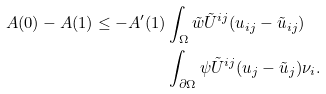<formula> <loc_0><loc_0><loc_500><loc_500>A ( 0 ) - A ( 1 ) \leq - A ^ { \prime } ( 1 ) & \int _ { \Omega } \tilde { w } \tilde { U } ^ { i j } ( u _ { i j } - \tilde { u } _ { i j } ) \\ & \int _ { \partial \Omega } \psi \tilde { U } ^ { i j } ( u _ { j } - \tilde { u } _ { j } ) \nu _ { i } .</formula> 